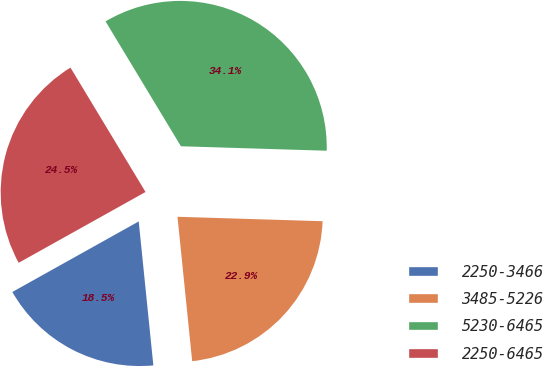<chart> <loc_0><loc_0><loc_500><loc_500><pie_chart><fcel>2250-3466<fcel>3485-5226<fcel>5230-6465<fcel>2250-6465<nl><fcel>18.51%<fcel>22.9%<fcel>34.13%<fcel>24.46%<nl></chart> 